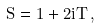Convert formula to latex. <formula><loc_0><loc_0><loc_500><loc_500>S = 1 + 2 i T \, ,</formula> 